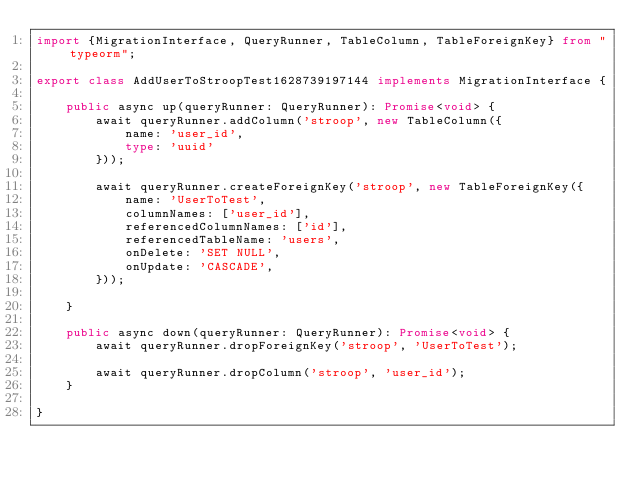Convert code to text. <code><loc_0><loc_0><loc_500><loc_500><_TypeScript_>import {MigrationInterface, QueryRunner, TableColumn, TableForeignKey} from "typeorm";

export class AddUserToStroopTest1628739197144 implements MigrationInterface {

    public async up(queryRunner: QueryRunner): Promise<void> {
        await queryRunner.addColumn('stroop', new TableColumn({
            name: 'user_id',
            type: 'uuid'
        }));

        await queryRunner.createForeignKey('stroop', new TableForeignKey({
            name: 'UserToTest',
            columnNames: ['user_id'],
            referencedColumnNames: ['id'],
            referencedTableName: 'users',
            onDelete: 'SET NULL',
            onUpdate: 'CASCADE',
        })); 

    }

    public async down(queryRunner: QueryRunner): Promise<void> {
        await queryRunner.dropForeignKey('stroop', 'UserToTest');
        
        await queryRunner.dropColumn('stroop', 'user_id');
    }

}</code> 